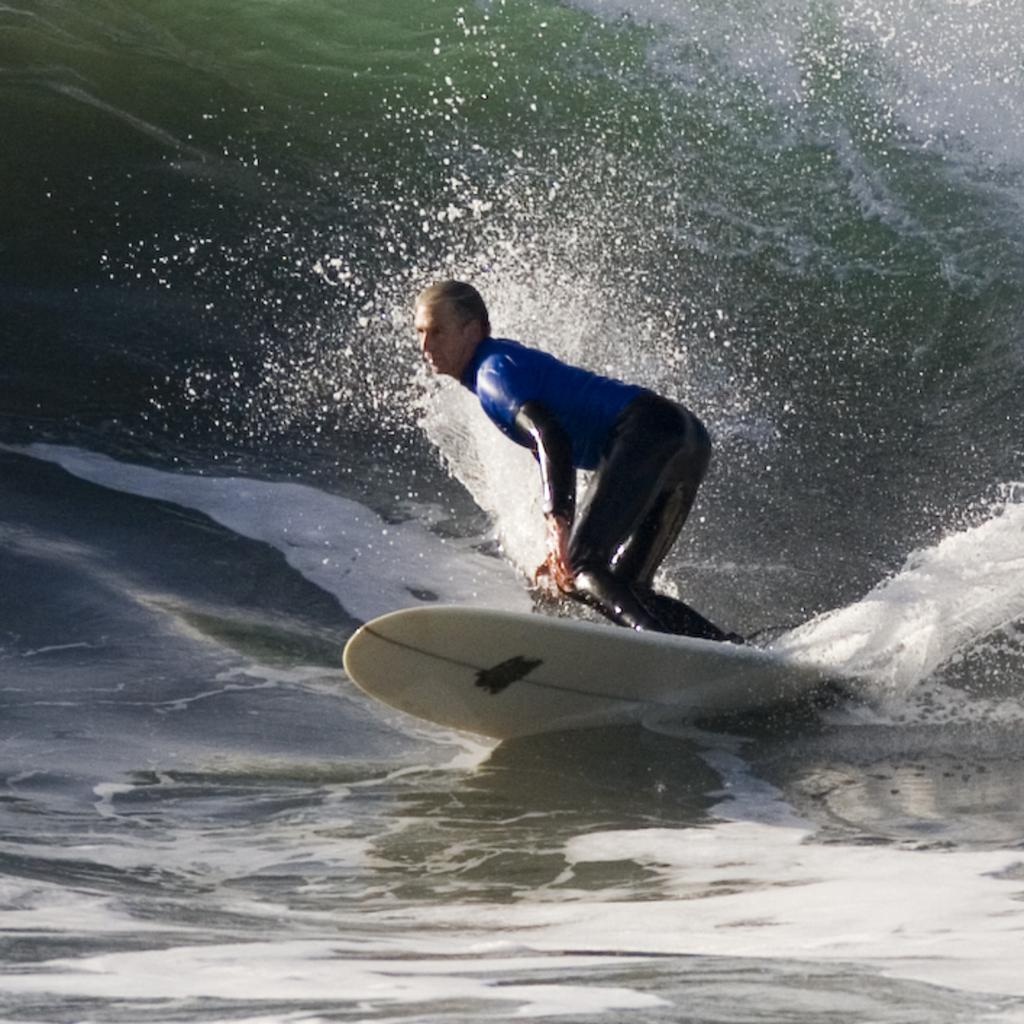What is the main subject of the image? The main subject of the image is a man. What is the man doing in the image? The man is surfing on the surface of the water. What type of skate is the man using to surf in the image? The man is not using a skate to surf in the image; he is surfing on the surface of the water using a surfboard. How does the sugar and mint affect the man's surfing experience in the image? There is no mention of sugar or mint in the image, so it cannot be determined how they would affect the man's surfing experience. 